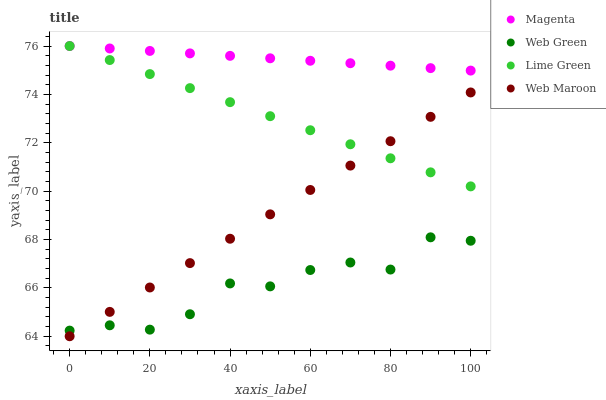Does Web Green have the minimum area under the curve?
Answer yes or no. Yes. Does Magenta have the maximum area under the curve?
Answer yes or no. Yes. Does Lime Green have the minimum area under the curve?
Answer yes or no. No. Does Lime Green have the maximum area under the curve?
Answer yes or no. No. Is Magenta the smoothest?
Answer yes or no. Yes. Is Web Green the roughest?
Answer yes or no. Yes. Is Lime Green the smoothest?
Answer yes or no. No. Is Lime Green the roughest?
Answer yes or no. No. Does Web Maroon have the lowest value?
Answer yes or no. Yes. Does Lime Green have the lowest value?
Answer yes or no. No. Does Lime Green have the highest value?
Answer yes or no. Yes. Does Web Green have the highest value?
Answer yes or no. No. Is Web Green less than Lime Green?
Answer yes or no. Yes. Is Lime Green greater than Web Green?
Answer yes or no. Yes. Does Web Maroon intersect Web Green?
Answer yes or no. Yes. Is Web Maroon less than Web Green?
Answer yes or no. No. Is Web Maroon greater than Web Green?
Answer yes or no. No. Does Web Green intersect Lime Green?
Answer yes or no. No. 